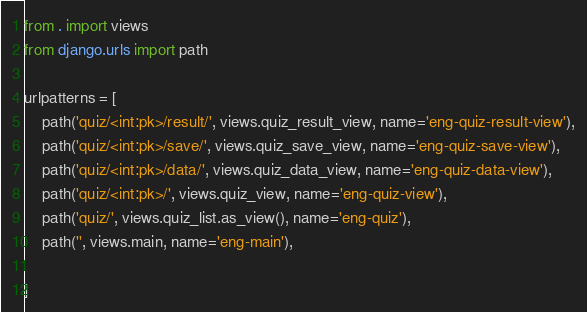<code> <loc_0><loc_0><loc_500><loc_500><_Python_>from . import views
from django.urls import path

urlpatterns = [
    path('quiz/<int:pk>/result/', views.quiz_result_view, name='eng-quiz-result-view'),
    path('quiz/<int:pk>/save/', views.quiz_save_view, name='eng-quiz-save-view'),
    path('quiz/<int:pk>/data/', views.quiz_data_view, name='eng-quiz-data-view'),
    path('quiz/<int:pk>/', views.quiz_view, name='eng-quiz-view'),
    path('quiz/', views.quiz_list.as_view(), name='eng-quiz'),
    path('', views.main, name='eng-main'),

]</code> 